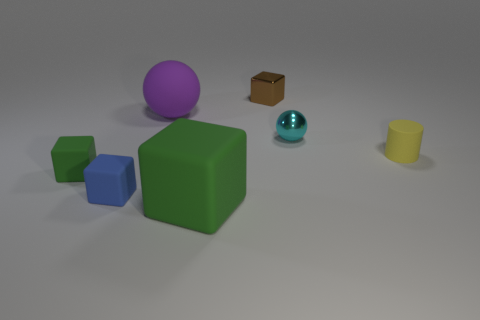Subtract all large blocks. How many blocks are left? 3 Subtract all brown cubes. How many cubes are left? 3 Subtract 0 brown spheres. How many objects are left? 7 Subtract all balls. How many objects are left? 5 Subtract 1 cylinders. How many cylinders are left? 0 Subtract all yellow blocks. Subtract all brown balls. How many blocks are left? 4 Subtract all cyan spheres. How many gray cubes are left? 0 Subtract all large things. Subtract all tiny metal cubes. How many objects are left? 4 Add 4 large green rubber objects. How many large green rubber objects are left? 5 Add 3 tiny yellow spheres. How many tiny yellow spheres exist? 3 